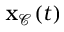<formula> <loc_0><loc_0><loc_500><loc_500>x _ { \mathcal { C } } ( t )</formula> 